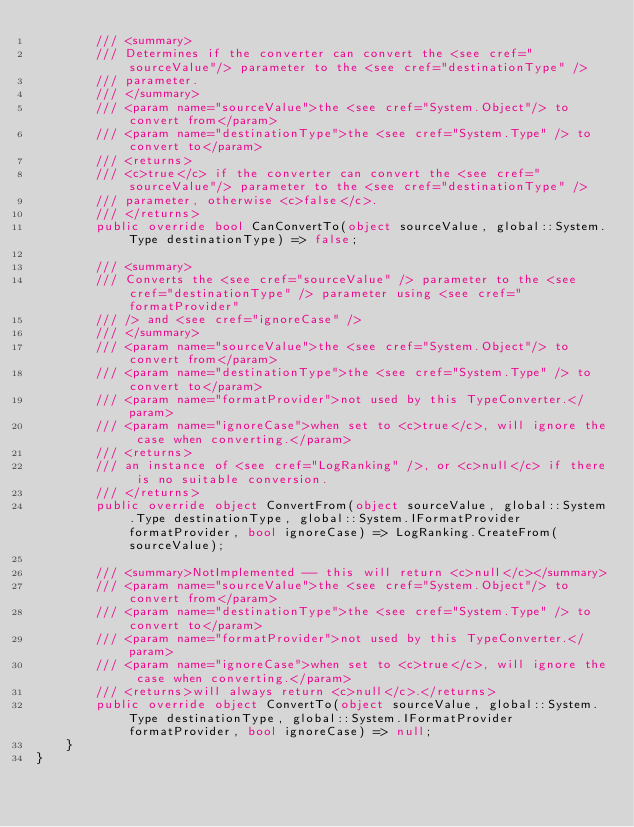<code> <loc_0><loc_0><loc_500><loc_500><_C#_>        /// <summary>
        /// Determines if the converter can convert the <see cref="sourceValue"/> parameter to the <see cref="destinationType" />
        /// parameter.
        /// </summary>
        /// <param name="sourceValue">the <see cref="System.Object"/> to convert from</param>
        /// <param name="destinationType">the <see cref="System.Type" /> to convert to</param>
        /// <returns>
        /// <c>true</c> if the converter can convert the <see cref="sourceValue"/> parameter to the <see cref="destinationType" />
        /// parameter, otherwise <c>false</c>.
        /// </returns>
        public override bool CanConvertTo(object sourceValue, global::System.Type destinationType) => false;

        /// <summary>
        /// Converts the <see cref="sourceValue" /> parameter to the <see cref="destinationType" /> parameter using <see cref="formatProvider"
        /// /> and <see cref="ignoreCase" />
        /// </summary>
        /// <param name="sourceValue">the <see cref="System.Object"/> to convert from</param>
        /// <param name="destinationType">the <see cref="System.Type" /> to convert to</param>
        /// <param name="formatProvider">not used by this TypeConverter.</param>
        /// <param name="ignoreCase">when set to <c>true</c>, will ignore the case when converting.</param>
        /// <returns>
        /// an instance of <see cref="LogRanking" />, or <c>null</c> if there is no suitable conversion.
        /// </returns>
        public override object ConvertFrom(object sourceValue, global::System.Type destinationType, global::System.IFormatProvider formatProvider, bool ignoreCase) => LogRanking.CreateFrom(sourceValue);

        /// <summary>NotImplemented -- this will return <c>null</c></summary>
        /// <param name="sourceValue">the <see cref="System.Object"/> to convert from</param>
        /// <param name="destinationType">the <see cref="System.Type" /> to convert to</param>
        /// <param name="formatProvider">not used by this TypeConverter.</param>
        /// <param name="ignoreCase">when set to <c>true</c>, will ignore the case when converting.</param>
        /// <returns>will always return <c>null</c>.</returns>
        public override object ConvertTo(object sourceValue, global::System.Type destinationType, global::System.IFormatProvider formatProvider, bool ignoreCase) => null;
    }
}</code> 